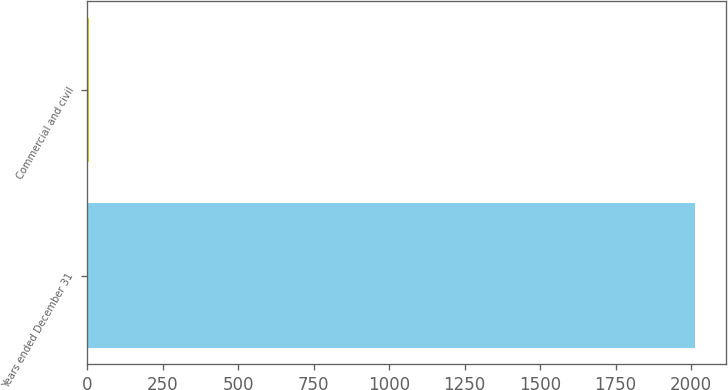Convert chart to OTSL. <chart><loc_0><loc_0><loc_500><loc_500><bar_chart><fcel>Years ended December 31<fcel>Commercial and civil<nl><fcel>2014<fcel>5<nl></chart> 